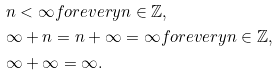<formula> <loc_0><loc_0><loc_500><loc_500>& n < \infty f o r e v e r y n \in \mathbb { Z } , \\ & \infty + n = n + \infty = \infty f o r e v e r y n \in \mathbb { Z } , \\ & \infty + \infty = \infty .</formula> 